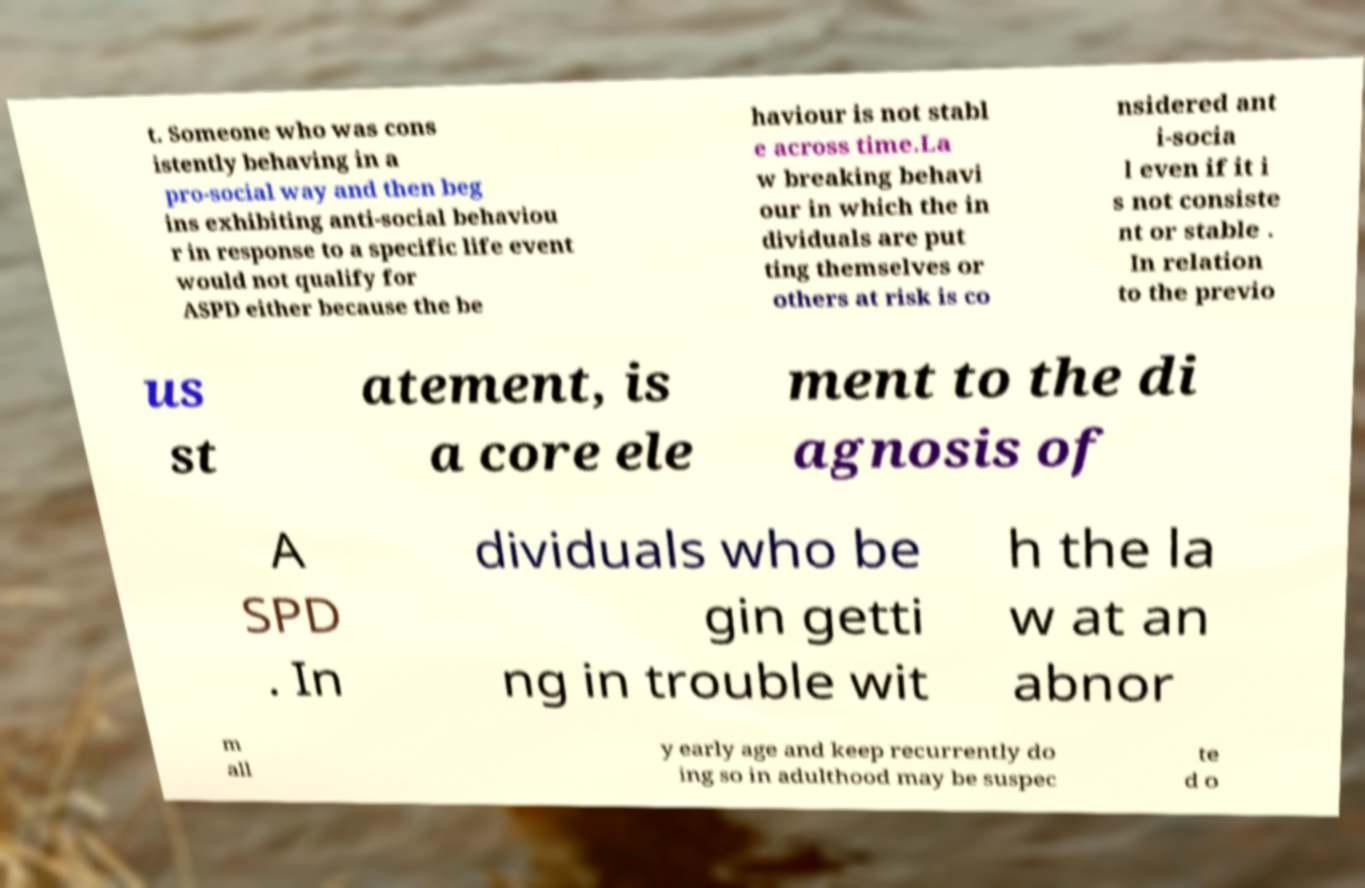For documentation purposes, I need the text within this image transcribed. Could you provide that? t. Someone who was cons istently behaving in a pro-social way and then beg ins exhibiting anti-social behaviou r in response to a specific life event would not qualify for ASPD either because the be haviour is not stabl e across time.La w breaking behavi our in which the in dividuals are put ting themselves or others at risk is co nsidered ant i-socia l even if it i s not consiste nt or stable . In relation to the previo us st atement, is a core ele ment to the di agnosis of A SPD . In dividuals who be gin getti ng in trouble wit h the la w at an abnor m all y early age and keep recurrently do ing so in adulthood may be suspec te d o 